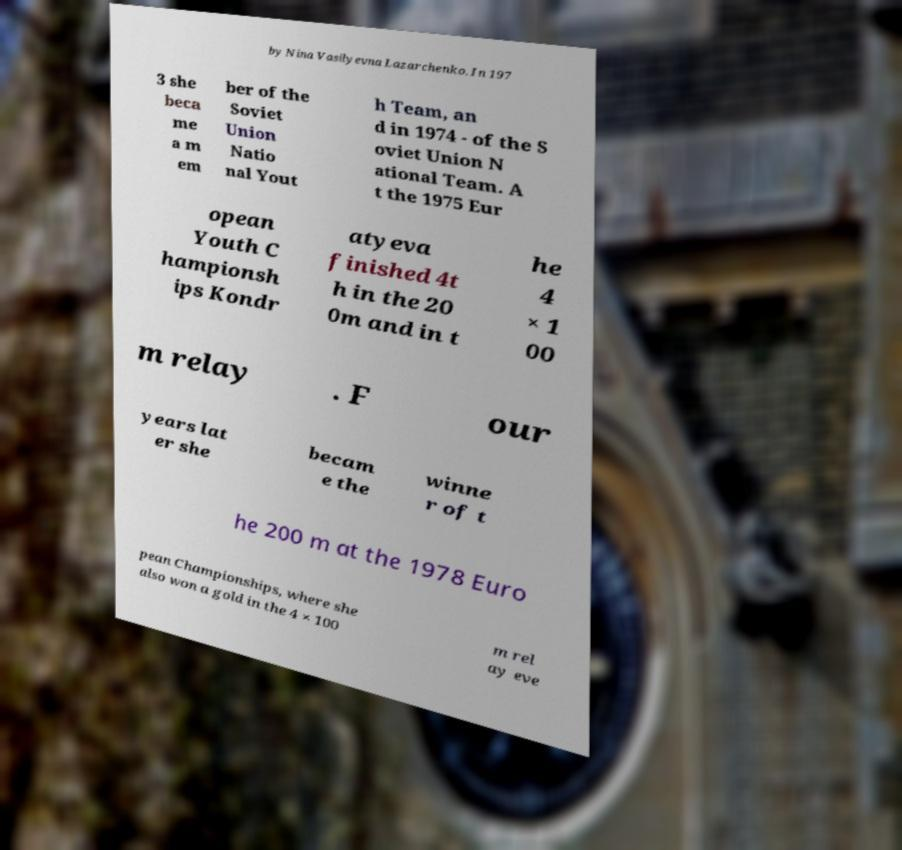For documentation purposes, I need the text within this image transcribed. Could you provide that? by Nina Vasilyevna Lazarchenko. In 197 3 she beca me a m em ber of the Soviet Union Natio nal Yout h Team, an d in 1974 - of the S oviet Union N ational Team. A t the 1975 Eur opean Youth C hampionsh ips Kondr atyeva finished 4t h in the 20 0m and in t he 4 × 1 00 m relay . F our years lat er she becam e the winne r of t he 200 m at the 1978 Euro pean Championships, where she also won a gold in the 4 × 100 m rel ay eve 